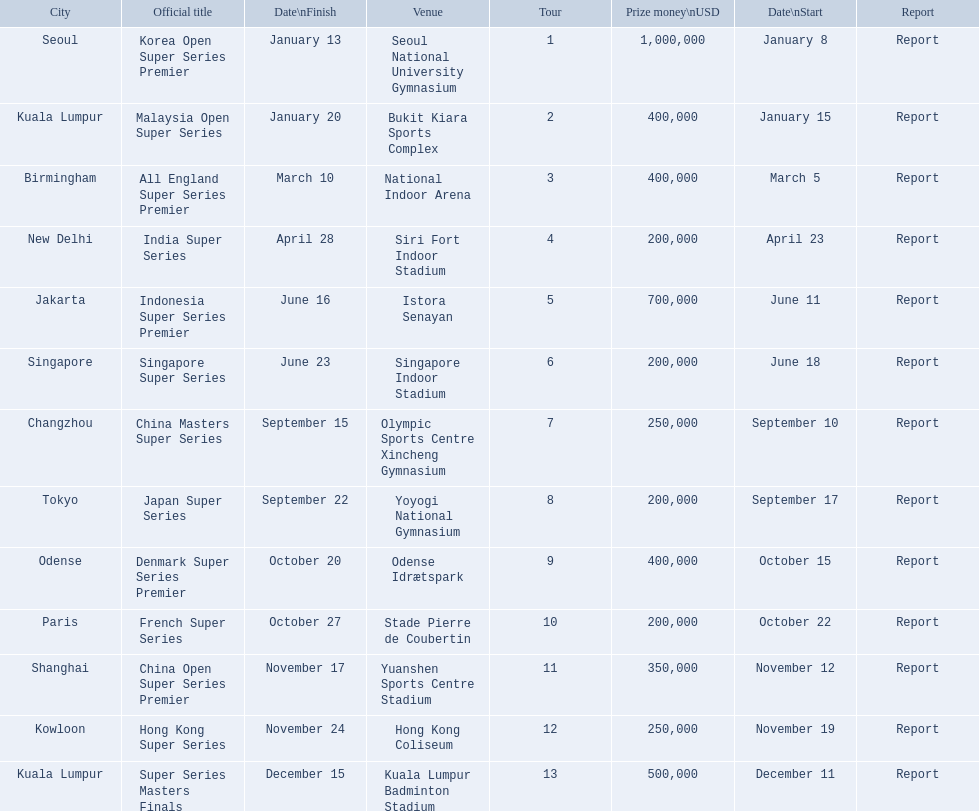What are all the tours? Korea Open Super Series Premier, Malaysia Open Super Series, All England Super Series Premier, India Super Series, Indonesia Super Series Premier, Singapore Super Series, China Masters Super Series, Japan Super Series, Denmark Super Series Premier, French Super Series, China Open Super Series Premier, Hong Kong Super Series, Super Series Masters Finals. What were the start dates of these tours? January 8, January 15, March 5, April 23, June 11, June 18, September 10, September 17, October 15, October 22, November 12, November 19, December 11. Of these, which is in december? December 11. Which tour started on this date? Super Series Masters Finals. 